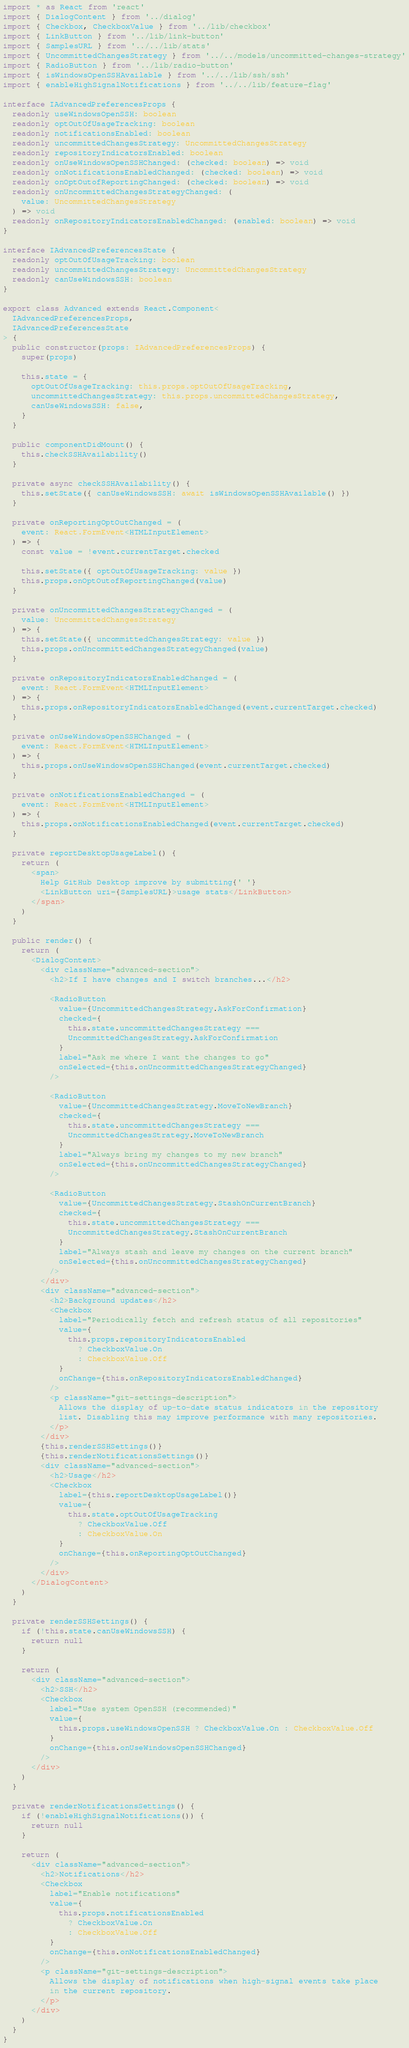<code> <loc_0><loc_0><loc_500><loc_500><_TypeScript_>import * as React from 'react'
import { DialogContent } from '../dialog'
import { Checkbox, CheckboxValue } from '../lib/checkbox'
import { LinkButton } from '../lib/link-button'
import { SamplesURL } from '../../lib/stats'
import { UncommittedChangesStrategy } from '../../models/uncommitted-changes-strategy'
import { RadioButton } from '../lib/radio-button'
import { isWindowsOpenSSHAvailable } from '../../lib/ssh/ssh'
import { enableHighSignalNotifications } from '../../lib/feature-flag'

interface IAdvancedPreferencesProps {
  readonly useWindowsOpenSSH: boolean
  readonly optOutOfUsageTracking: boolean
  readonly notificationsEnabled: boolean
  readonly uncommittedChangesStrategy: UncommittedChangesStrategy
  readonly repositoryIndicatorsEnabled: boolean
  readonly onUseWindowsOpenSSHChanged: (checked: boolean) => void
  readonly onNotificationsEnabledChanged: (checked: boolean) => void
  readonly onOptOutofReportingChanged: (checked: boolean) => void
  readonly onUncommittedChangesStrategyChanged: (
    value: UncommittedChangesStrategy
  ) => void
  readonly onRepositoryIndicatorsEnabledChanged: (enabled: boolean) => void
}

interface IAdvancedPreferencesState {
  readonly optOutOfUsageTracking: boolean
  readonly uncommittedChangesStrategy: UncommittedChangesStrategy
  readonly canUseWindowsSSH: boolean
}

export class Advanced extends React.Component<
  IAdvancedPreferencesProps,
  IAdvancedPreferencesState
> {
  public constructor(props: IAdvancedPreferencesProps) {
    super(props)

    this.state = {
      optOutOfUsageTracking: this.props.optOutOfUsageTracking,
      uncommittedChangesStrategy: this.props.uncommittedChangesStrategy,
      canUseWindowsSSH: false,
    }
  }

  public componentDidMount() {
    this.checkSSHAvailability()
  }

  private async checkSSHAvailability() {
    this.setState({ canUseWindowsSSH: await isWindowsOpenSSHAvailable() })
  }

  private onReportingOptOutChanged = (
    event: React.FormEvent<HTMLInputElement>
  ) => {
    const value = !event.currentTarget.checked

    this.setState({ optOutOfUsageTracking: value })
    this.props.onOptOutofReportingChanged(value)
  }

  private onUncommittedChangesStrategyChanged = (
    value: UncommittedChangesStrategy
  ) => {
    this.setState({ uncommittedChangesStrategy: value })
    this.props.onUncommittedChangesStrategyChanged(value)
  }

  private onRepositoryIndicatorsEnabledChanged = (
    event: React.FormEvent<HTMLInputElement>
  ) => {
    this.props.onRepositoryIndicatorsEnabledChanged(event.currentTarget.checked)
  }

  private onUseWindowsOpenSSHChanged = (
    event: React.FormEvent<HTMLInputElement>
  ) => {
    this.props.onUseWindowsOpenSSHChanged(event.currentTarget.checked)
  }

  private onNotificationsEnabledChanged = (
    event: React.FormEvent<HTMLInputElement>
  ) => {
    this.props.onNotificationsEnabledChanged(event.currentTarget.checked)
  }

  private reportDesktopUsageLabel() {
    return (
      <span>
        Help GitHub Desktop improve by submitting{' '}
        <LinkButton uri={SamplesURL}>usage stats</LinkButton>
      </span>
    )
  }

  public render() {
    return (
      <DialogContent>
        <div className="advanced-section">
          <h2>If I have changes and I switch branches...</h2>

          <RadioButton
            value={UncommittedChangesStrategy.AskForConfirmation}
            checked={
              this.state.uncommittedChangesStrategy ===
              UncommittedChangesStrategy.AskForConfirmation
            }
            label="Ask me where I want the changes to go"
            onSelected={this.onUncommittedChangesStrategyChanged}
          />

          <RadioButton
            value={UncommittedChangesStrategy.MoveToNewBranch}
            checked={
              this.state.uncommittedChangesStrategy ===
              UncommittedChangesStrategy.MoveToNewBranch
            }
            label="Always bring my changes to my new branch"
            onSelected={this.onUncommittedChangesStrategyChanged}
          />

          <RadioButton
            value={UncommittedChangesStrategy.StashOnCurrentBranch}
            checked={
              this.state.uncommittedChangesStrategy ===
              UncommittedChangesStrategy.StashOnCurrentBranch
            }
            label="Always stash and leave my changes on the current branch"
            onSelected={this.onUncommittedChangesStrategyChanged}
          />
        </div>
        <div className="advanced-section">
          <h2>Background updates</h2>
          <Checkbox
            label="Periodically fetch and refresh status of all repositories"
            value={
              this.props.repositoryIndicatorsEnabled
                ? CheckboxValue.On
                : CheckboxValue.Off
            }
            onChange={this.onRepositoryIndicatorsEnabledChanged}
          />
          <p className="git-settings-description">
            Allows the display of up-to-date status indicators in the repository
            list. Disabling this may improve performance with many repositories.
          </p>
        </div>
        {this.renderSSHSettings()}
        {this.renderNotificationsSettings()}
        <div className="advanced-section">
          <h2>Usage</h2>
          <Checkbox
            label={this.reportDesktopUsageLabel()}
            value={
              this.state.optOutOfUsageTracking
                ? CheckboxValue.Off
                : CheckboxValue.On
            }
            onChange={this.onReportingOptOutChanged}
          />
        </div>
      </DialogContent>
    )
  }

  private renderSSHSettings() {
    if (!this.state.canUseWindowsSSH) {
      return null
    }

    return (
      <div className="advanced-section">
        <h2>SSH</h2>
        <Checkbox
          label="Use system OpenSSH (recommended)"
          value={
            this.props.useWindowsOpenSSH ? CheckboxValue.On : CheckboxValue.Off
          }
          onChange={this.onUseWindowsOpenSSHChanged}
        />
      </div>
    )
  }

  private renderNotificationsSettings() {
    if (!enableHighSignalNotifications()) {
      return null
    }

    return (
      <div className="advanced-section">
        <h2>Notifications</h2>
        <Checkbox
          label="Enable notifications"
          value={
            this.props.notificationsEnabled
              ? CheckboxValue.On
              : CheckboxValue.Off
          }
          onChange={this.onNotificationsEnabledChanged}
        />
        <p className="git-settings-description">
          Allows the display of notifications when high-signal events take place
          in the current repository.
        </p>
      </div>
    )
  }
}
</code> 